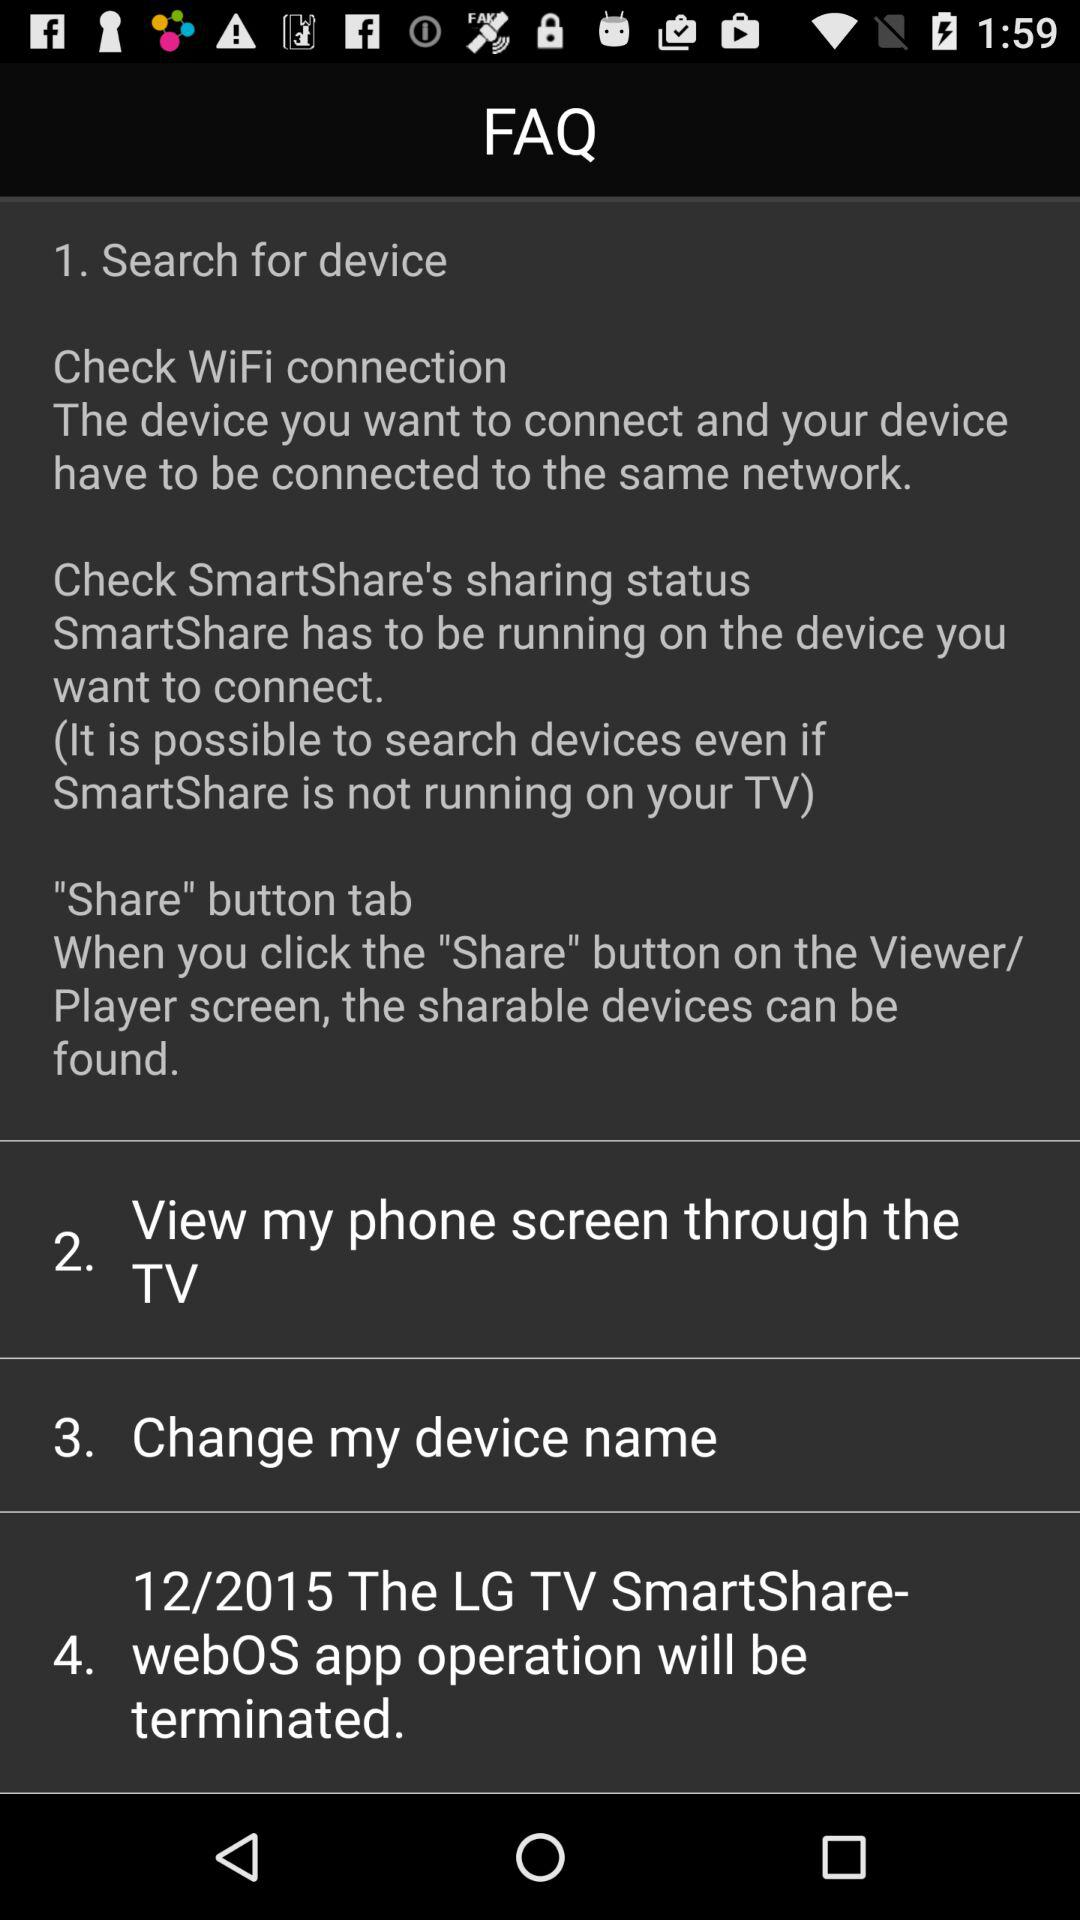How many steps are there in the FAQ?
Answer the question using a single word or phrase. 4 